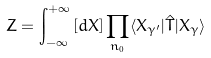<formula> <loc_0><loc_0><loc_500><loc_500>Z = \int _ { - \infty } ^ { + \infty } \left [ d X \right ] \prod _ { n _ { 0 } } \langle X _ { \gamma ^ { \prime } } | \hat { T } | X _ { \gamma } \rangle</formula> 